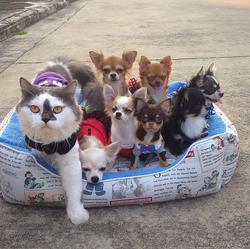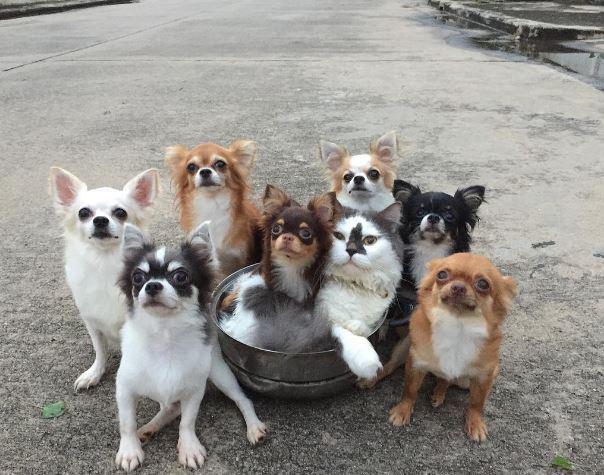The first image is the image on the left, the second image is the image on the right. Assess this claim about the two images: "The sleeping cat is snuggling with a dog in the image on the right.". Correct or not? Answer yes or no. No. 